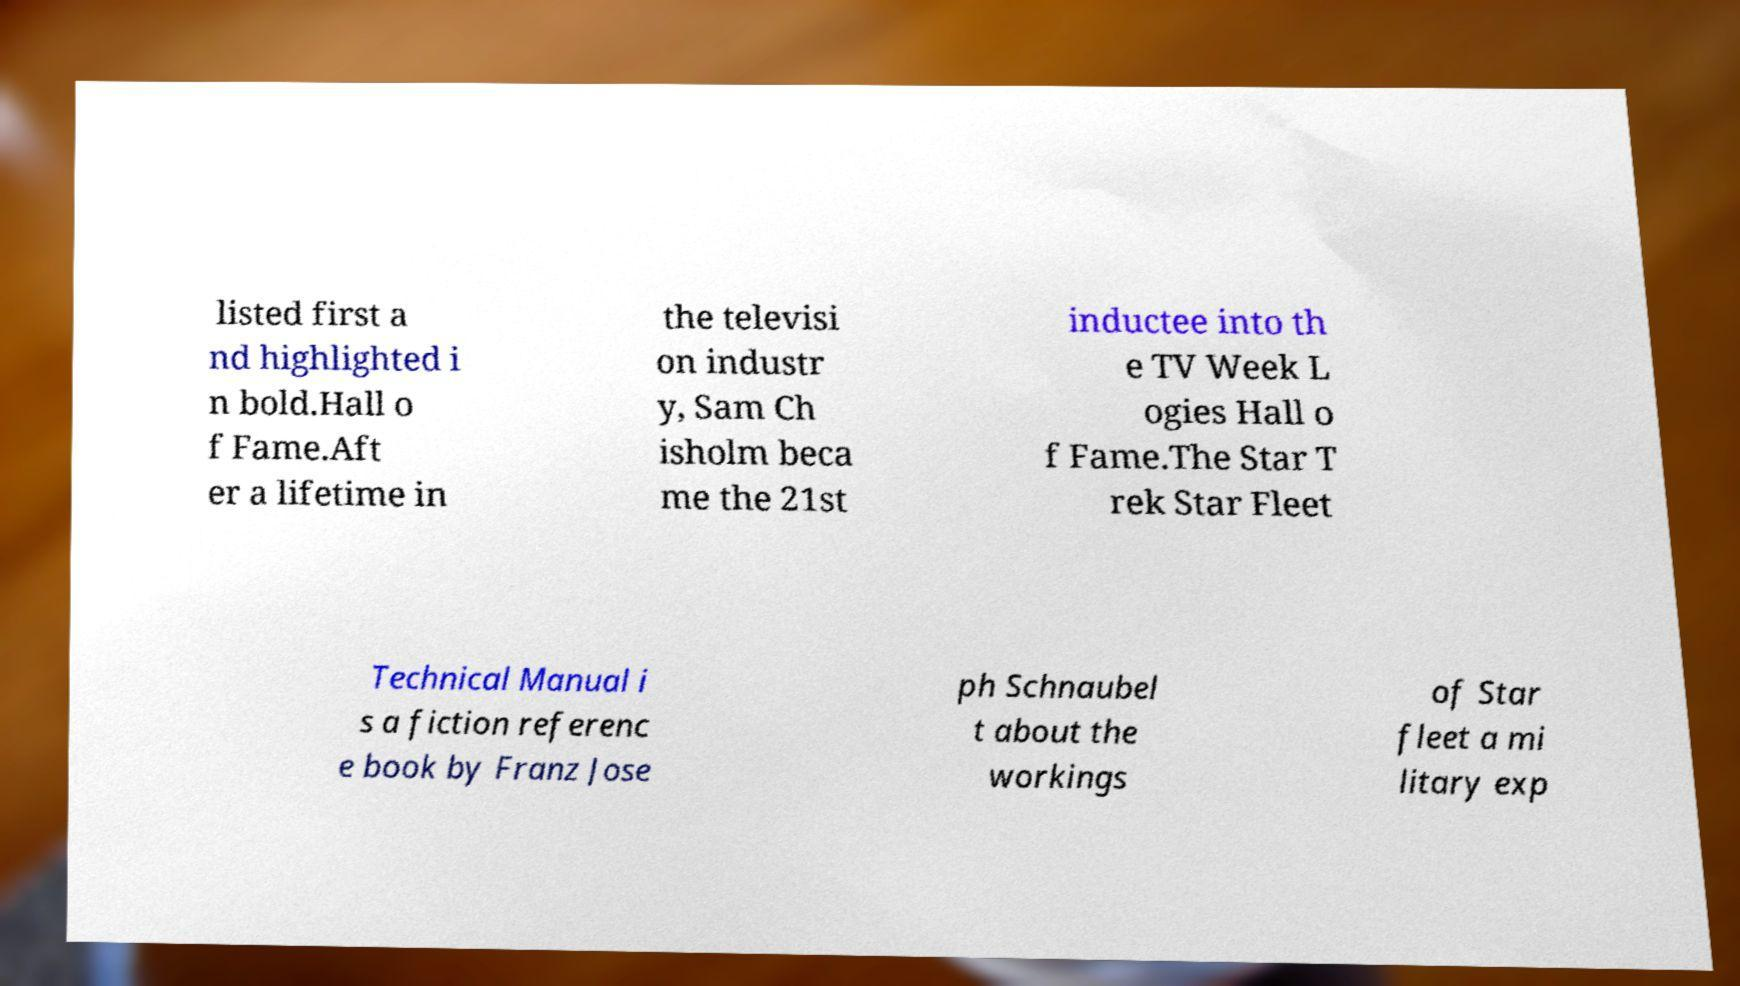Could you extract and type out the text from this image? listed first a nd highlighted i n bold.Hall o f Fame.Aft er a lifetime in the televisi on industr y, Sam Ch isholm beca me the 21st inductee into th e TV Week L ogies Hall o f Fame.The Star T rek Star Fleet Technical Manual i s a fiction referenc e book by Franz Jose ph Schnaubel t about the workings of Star fleet a mi litary exp 